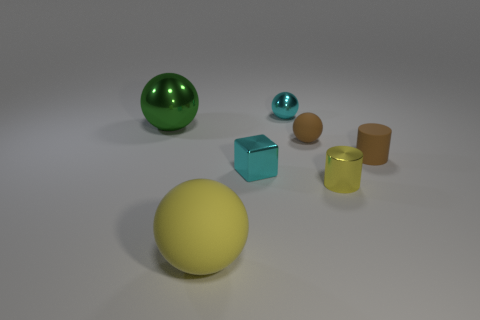Which objects in the image have reflective surfaces? The large green ball and the blue cube reflect light and showcase glossy surfaces that depict their surroundings faintly, indicative of their reflective properties. 